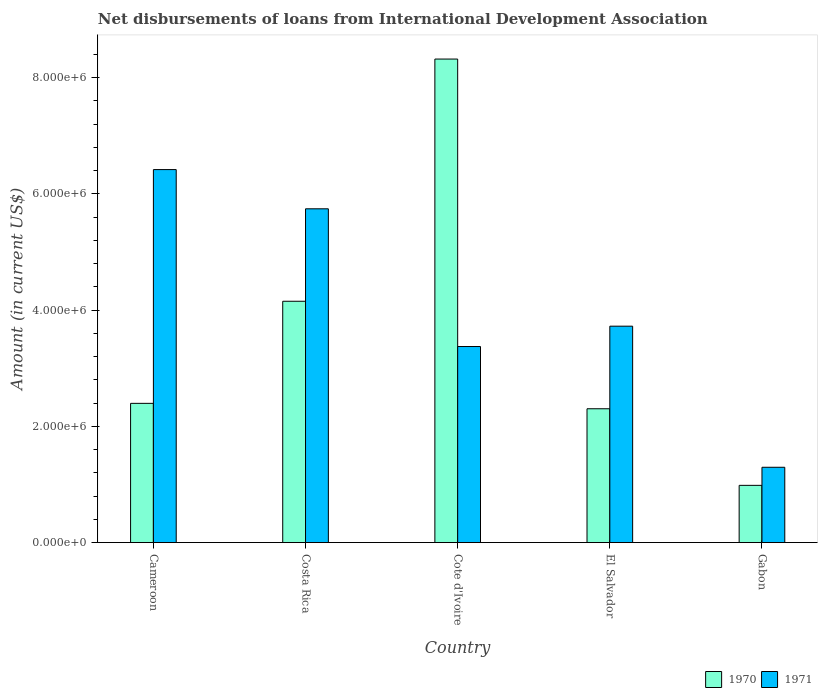How many different coloured bars are there?
Keep it short and to the point. 2. How many groups of bars are there?
Provide a succinct answer. 5. How many bars are there on the 4th tick from the right?
Your answer should be very brief. 2. What is the label of the 5th group of bars from the left?
Your response must be concise. Gabon. In how many cases, is the number of bars for a given country not equal to the number of legend labels?
Give a very brief answer. 0. What is the amount of loans disbursed in 1971 in Costa Rica?
Offer a very short reply. 5.74e+06. Across all countries, what is the maximum amount of loans disbursed in 1970?
Your response must be concise. 8.32e+06. Across all countries, what is the minimum amount of loans disbursed in 1971?
Offer a very short reply. 1.30e+06. In which country was the amount of loans disbursed in 1971 maximum?
Your answer should be compact. Cameroon. In which country was the amount of loans disbursed in 1971 minimum?
Provide a succinct answer. Gabon. What is the total amount of loans disbursed in 1970 in the graph?
Make the answer very short. 1.82e+07. What is the difference between the amount of loans disbursed in 1971 in Cote d'Ivoire and that in Gabon?
Provide a succinct answer. 2.08e+06. What is the difference between the amount of loans disbursed in 1971 in El Salvador and the amount of loans disbursed in 1970 in Cameroon?
Your answer should be compact. 1.33e+06. What is the average amount of loans disbursed in 1971 per country?
Offer a terse response. 4.11e+06. What is the difference between the amount of loans disbursed of/in 1970 and amount of loans disbursed of/in 1971 in Costa Rica?
Your response must be concise. -1.59e+06. What is the ratio of the amount of loans disbursed in 1971 in Cameroon to that in Cote d'Ivoire?
Ensure brevity in your answer.  1.9. Is the difference between the amount of loans disbursed in 1970 in Cameroon and El Salvador greater than the difference between the amount of loans disbursed in 1971 in Cameroon and El Salvador?
Offer a very short reply. No. What is the difference between the highest and the second highest amount of loans disbursed in 1970?
Provide a short and direct response. 5.92e+06. What is the difference between the highest and the lowest amount of loans disbursed in 1970?
Offer a very short reply. 7.34e+06. Is the sum of the amount of loans disbursed in 1971 in Cote d'Ivoire and Gabon greater than the maximum amount of loans disbursed in 1970 across all countries?
Your answer should be compact. No. What does the 2nd bar from the right in Gabon represents?
Give a very brief answer. 1970. How many bars are there?
Provide a short and direct response. 10. Are all the bars in the graph horizontal?
Provide a short and direct response. No. Does the graph contain any zero values?
Give a very brief answer. No. Does the graph contain grids?
Offer a very short reply. No. How many legend labels are there?
Provide a succinct answer. 2. How are the legend labels stacked?
Give a very brief answer. Horizontal. What is the title of the graph?
Your answer should be very brief. Net disbursements of loans from International Development Association. What is the Amount (in current US$) in 1970 in Cameroon?
Offer a very short reply. 2.40e+06. What is the Amount (in current US$) of 1971 in Cameroon?
Offer a very short reply. 6.42e+06. What is the Amount (in current US$) in 1970 in Costa Rica?
Offer a very short reply. 4.15e+06. What is the Amount (in current US$) in 1971 in Costa Rica?
Offer a very short reply. 5.74e+06. What is the Amount (in current US$) in 1970 in Cote d'Ivoire?
Your answer should be very brief. 8.32e+06. What is the Amount (in current US$) in 1971 in Cote d'Ivoire?
Give a very brief answer. 3.37e+06. What is the Amount (in current US$) of 1970 in El Salvador?
Keep it short and to the point. 2.30e+06. What is the Amount (in current US$) of 1971 in El Salvador?
Offer a terse response. 3.72e+06. What is the Amount (in current US$) of 1970 in Gabon?
Provide a succinct answer. 9.85e+05. What is the Amount (in current US$) in 1971 in Gabon?
Offer a very short reply. 1.30e+06. Across all countries, what is the maximum Amount (in current US$) of 1970?
Ensure brevity in your answer.  8.32e+06. Across all countries, what is the maximum Amount (in current US$) in 1971?
Give a very brief answer. 6.42e+06. Across all countries, what is the minimum Amount (in current US$) in 1970?
Your answer should be very brief. 9.85e+05. Across all countries, what is the minimum Amount (in current US$) of 1971?
Your response must be concise. 1.30e+06. What is the total Amount (in current US$) in 1970 in the graph?
Make the answer very short. 1.82e+07. What is the total Amount (in current US$) of 1971 in the graph?
Ensure brevity in your answer.  2.06e+07. What is the difference between the Amount (in current US$) in 1970 in Cameroon and that in Costa Rica?
Give a very brief answer. -1.76e+06. What is the difference between the Amount (in current US$) of 1971 in Cameroon and that in Costa Rica?
Your answer should be very brief. 6.75e+05. What is the difference between the Amount (in current US$) of 1970 in Cameroon and that in Cote d'Ivoire?
Your answer should be compact. -5.92e+06. What is the difference between the Amount (in current US$) in 1971 in Cameroon and that in Cote d'Ivoire?
Keep it short and to the point. 3.04e+06. What is the difference between the Amount (in current US$) of 1970 in Cameroon and that in El Salvador?
Keep it short and to the point. 9.30e+04. What is the difference between the Amount (in current US$) in 1971 in Cameroon and that in El Salvador?
Ensure brevity in your answer.  2.70e+06. What is the difference between the Amount (in current US$) of 1970 in Cameroon and that in Gabon?
Provide a succinct answer. 1.41e+06. What is the difference between the Amount (in current US$) in 1971 in Cameroon and that in Gabon?
Your answer should be very brief. 5.12e+06. What is the difference between the Amount (in current US$) in 1970 in Costa Rica and that in Cote d'Ivoire?
Your answer should be very brief. -4.17e+06. What is the difference between the Amount (in current US$) of 1971 in Costa Rica and that in Cote d'Ivoire?
Keep it short and to the point. 2.37e+06. What is the difference between the Amount (in current US$) of 1970 in Costa Rica and that in El Salvador?
Provide a succinct answer. 1.85e+06. What is the difference between the Amount (in current US$) of 1971 in Costa Rica and that in El Salvador?
Your answer should be compact. 2.02e+06. What is the difference between the Amount (in current US$) in 1970 in Costa Rica and that in Gabon?
Provide a short and direct response. 3.17e+06. What is the difference between the Amount (in current US$) of 1971 in Costa Rica and that in Gabon?
Keep it short and to the point. 4.45e+06. What is the difference between the Amount (in current US$) in 1970 in Cote d'Ivoire and that in El Salvador?
Keep it short and to the point. 6.02e+06. What is the difference between the Amount (in current US$) in 1971 in Cote d'Ivoire and that in El Salvador?
Provide a short and direct response. -3.50e+05. What is the difference between the Amount (in current US$) of 1970 in Cote d'Ivoire and that in Gabon?
Provide a succinct answer. 7.34e+06. What is the difference between the Amount (in current US$) of 1971 in Cote d'Ivoire and that in Gabon?
Offer a very short reply. 2.08e+06. What is the difference between the Amount (in current US$) of 1970 in El Salvador and that in Gabon?
Ensure brevity in your answer.  1.32e+06. What is the difference between the Amount (in current US$) of 1971 in El Salvador and that in Gabon?
Provide a short and direct response. 2.43e+06. What is the difference between the Amount (in current US$) of 1970 in Cameroon and the Amount (in current US$) of 1971 in Costa Rica?
Your answer should be very brief. -3.35e+06. What is the difference between the Amount (in current US$) in 1970 in Cameroon and the Amount (in current US$) in 1971 in Cote d'Ivoire?
Ensure brevity in your answer.  -9.78e+05. What is the difference between the Amount (in current US$) of 1970 in Cameroon and the Amount (in current US$) of 1971 in El Salvador?
Offer a terse response. -1.33e+06. What is the difference between the Amount (in current US$) in 1970 in Cameroon and the Amount (in current US$) in 1971 in Gabon?
Your response must be concise. 1.10e+06. What is the difference between the Amount (in current US$) in 1970 in Costa Rica and the Amount (in current US$) in 1971 in Cote d'Ivoire?
Your response must be concise. 7.79e+05. What is the difference between the Amount (in current US$) of 1970 in Costa Rica and the Amount (in current US$) of 1971 in El Salvador?
Provide a short and direct response. 4.29e+05. What is the difference between the Amount (in current US$) of 1970 in Costa Rica and the Amount (in current US$) of 1971 in Gabon?
Your response must be concise. 2.86e+06. What is the difference between the Amount (in current US$) of 1970 in Cote d'Ivoire and the Amount (in current US$) of 1971 in El Salvador?
Provide a succinct answer. 4.60e+06. What is the difference between the Amount (in current US$) in 1970 in Cote d'Ivoire and the Amount (in current US$) in 1971 in Gabon?
Make the answer very short. 7.02e+06. What is the difference between the Amount (in current US$) of 1970 in El Salvador and the Amount (in current US$) of 1971 in Gabon?
Your answer should be very brief. 1.01e+06. What is the average Amount (in current US$) in 1970 per country?
Offer a terse response. 3.63e+06. What is the average Amount (in current US$) of 1971 per country?
Ensure brevity in your answer.  4.11e+06. What is the difference between the Amount (in current US$) in 1970 and Amount (in current US$) in 1971 in Cameroon?
Your response must be concise. -4.02e+06. What is the difference between the Amount (in current US$) in 1970 and Amount (in current US$) in 1971 in Costa Rica?
Offer a terse response. -1.59e+06. What is the difference between the Amount (in current US$) of 1970 and Amount (in current US$) of 1971 in Cote d'Ivoire?
Keep it short and to the point. 4.95e+06. What is the difference between the Amount (in current US$) in 1970 and Amount (in current US$) in 1971 in El Salvador?
Your answer should be compact. -1.42e+06. What is the difference between the Amount (in current US$) in 1970 and Amount (in current US$) in 1971 in Gabon?
Ensure brevity in your answer.  -3.11e+05. What is the ratio of the Amount (in current US$) of 1970 in Cameroon to that in Costa Rica?
Ensure brevity in your answer.  0.58. What is the ratio of the Amount (in current US$) of 1971 in Cameroon to that in Costa Rica?
Your response must be concise. 1.12. What is the ratio of the Amount (in current US$) in 1970 in Cameroon to that in Cote d'Ivoire?
Ensure brevity in your answer.  0.29. What is the ratio of the Amount (in current US$) of 1971 in Cameroon to that in Cote d'Ivoire?
Ensure brevity in your answer.  1.9. What is the ratio of the Amount (in current US$) of 1970 in Cameroon to that in El Salvador?
Ensure brevity in your answer.  1.04. What is the ratio of the Amount (in current US$) in 1971 in Cameroon to that in El Salvador?
Provide a succinct answer. 1.72. What is the ratio of the Amount (in current US$) of 1970 in Cameroon to that in Gabon?
Offer a terse response. 2.43. What is the ratio of the Amount (in current US$) in 1971 in Cameroon to that in Gabon?
Offer a terse response. 4.95. What is the ratio of the Amount (in current US$) of 1970 in Costa Rica to that in Cote d'Ivoire?
Provide a short and direct response. 0.5. What is the ratio of the Amount (in current US$) in 1971 in Costa Rica to that in Cote d'Ivoire?
Offer a terse response. 1.7. What is the ratio of the Amount (in current US$) in 1970 in Costa Rica to that in El Salvador?
Provide a succinct answer. 1.8. What is the ratio of the Amount (in current US$) of 1971 in Costa Rica to that in El Salvador?
Ensure brevity in your answer.  1.54. What is the ratio of the Amount (in current US$) of 1970 in Costa Rica to that in Gabon?
Provide a succinct answer. 4.22. What is the ratio of the Amount (in current US$) in 1971 in Costa Rica to that in Gabon?
Your answer should be compact. 4.43. What is the ratio of the Amount (in current US$) of 1970 in Cote d'Ivoire to that in El Salvador?
Your answer should be compact. 3.61. What is the ratio of the Amount (in current US$) of 1971 in Cote d'Ivoire to that in El Salvador?
Give a very brief answer. 0.91. What is the ratio of the Amount (in current US$) in 1970 in Cote d'Ivoire to that in Gabon?
Give a very brief answer. 8.45. What is the ratio of the Amount (in current US$) of 1971 in Cote d'Ivoire to that in Gabon?
Offer a very short reply. 2.6. What is the ratio of the Amount (in current US$) in 1970 in El Salvador to that in Gabon?
Give a very brief answer. 2.34. What is the ratio of the Amount (in current US$) in 1971 in El Salvador to that in Gabon?
Offer a very short reply. 2.87. What is the difference between the highest and the second highest Amount (in current US$) of 1970?
Offer a terse response. 4.17e+06. What is the difference between the highest and the second highest Amount (in current US$) in 1971?
Ensure brevity in your answer.  6.75e+05. What is the difference between the highest and the lowest Amount (in current US$) in 1970?
Your answer should be very brief. 7.34e+06. What is the difference between the highest and the lowest Amount (in current US$) in 1971?
Your answer should be compact. 5.12e+06. 